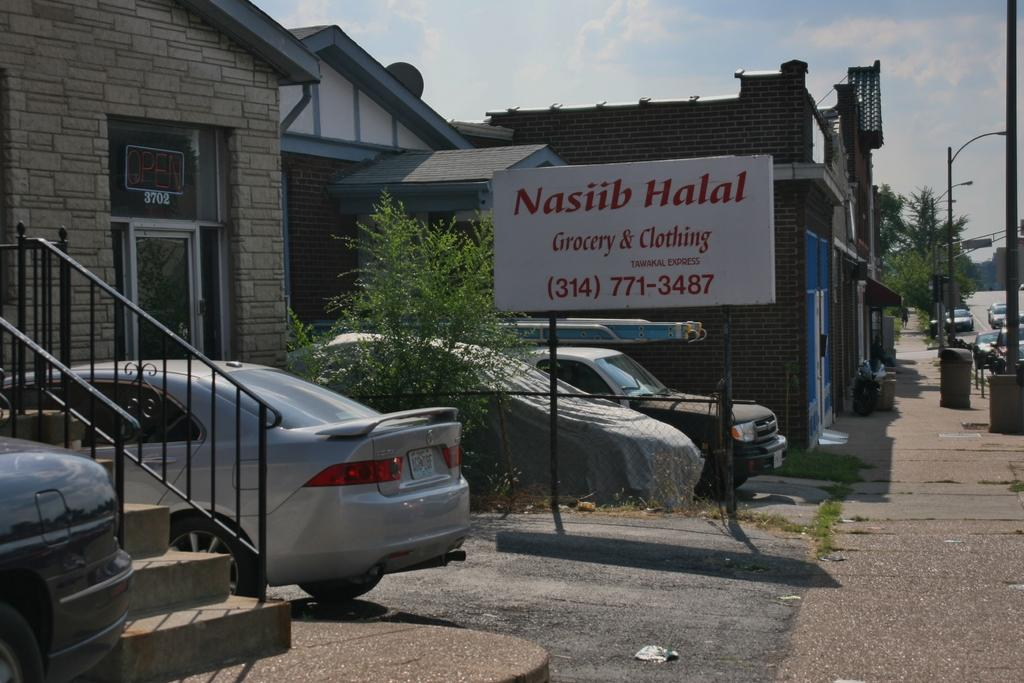What type of structures can be seen in the image? There are houses in the image. What natural elements are present in the image? There are trees in the image. What man-made objects can be seen in the image? There are poles and cars in the image. What additional object is present to the side in the image? There is a board to the side in the image. Can you see a frog hopping on the board in the image? There is no frog present in the image; it only features houses, trees, poles, cars, and a board. What type of flag is flying on the pole in the image? There is no flag present on the poles in the image. 